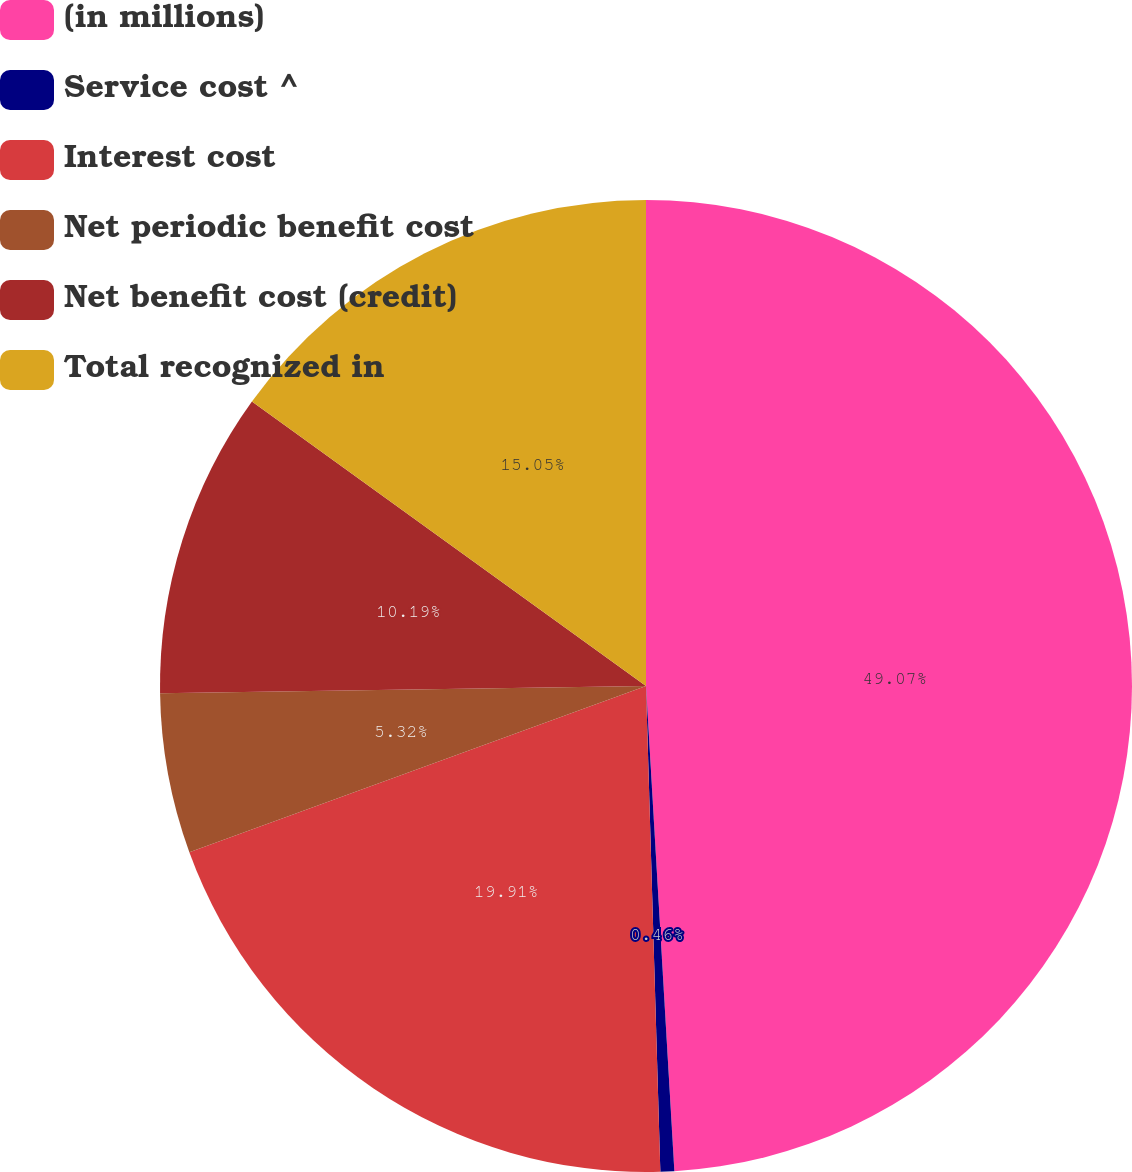Convert chart to OTSL. <chart><loc_0><loc_0><loc_500><loc_500><pie_chart><fcel>(in millions)<fcel>Service cost ^<fcel>Interest cost<fcel>Net periodic benefit cost<fcel>Net benefit cost (credit)<fcel>Total recognized in<nl><fcel>49.07%<fcel>0.46%<fcel>19.91%<fcel>5.32%<fcel>10.19%<fcel>15.05%<nl></chart> 